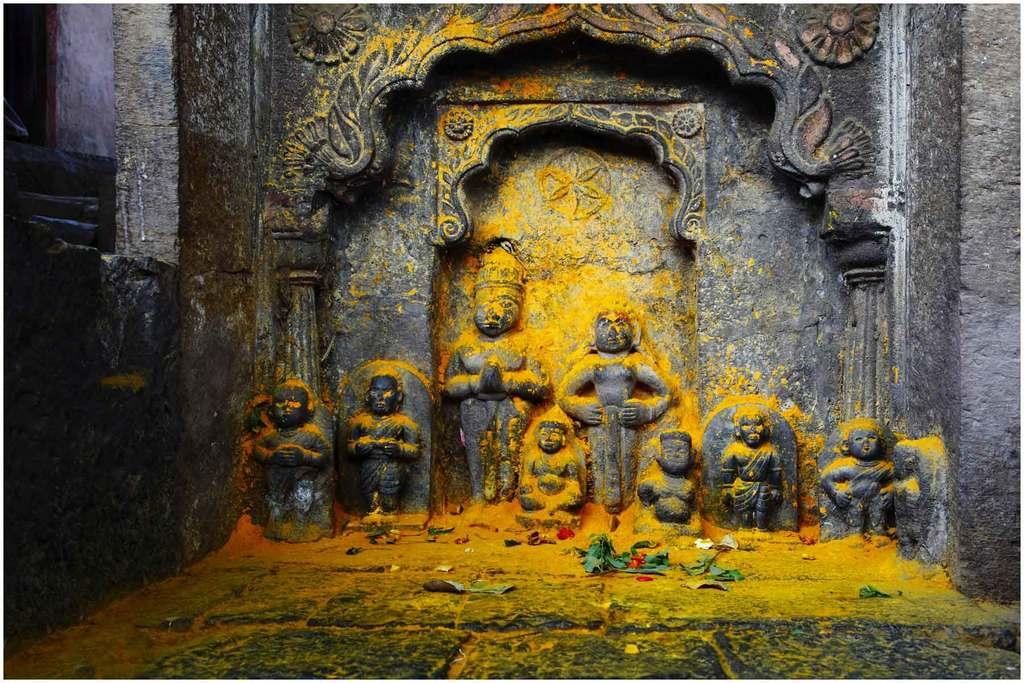What is the main subject in the center of the image? There are sculptures in the center of the image. What can be seen in the background of the image? There is a wall in the background of the image. What type of vegetation is present at the bottom of the image? There are leaves at the bottom of the image. What else can be found at the bottom of the image besides leaves? There are objects at the bottom of the image. What type of fruit is hanging from the sculptures in the image? There is no fruit present in the image; it features sculptures and other elements mentioned in the conversation. 